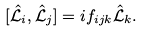<formula> <loc_0><loc_0><loc_500><loc_500>[ \hat { \mathcal { L } } _ { i } , \hat { \mathcal { L } } _ { j } ] = i f _ { i j k } \hat { \mathcal { L } } _ { k } .</formula> 